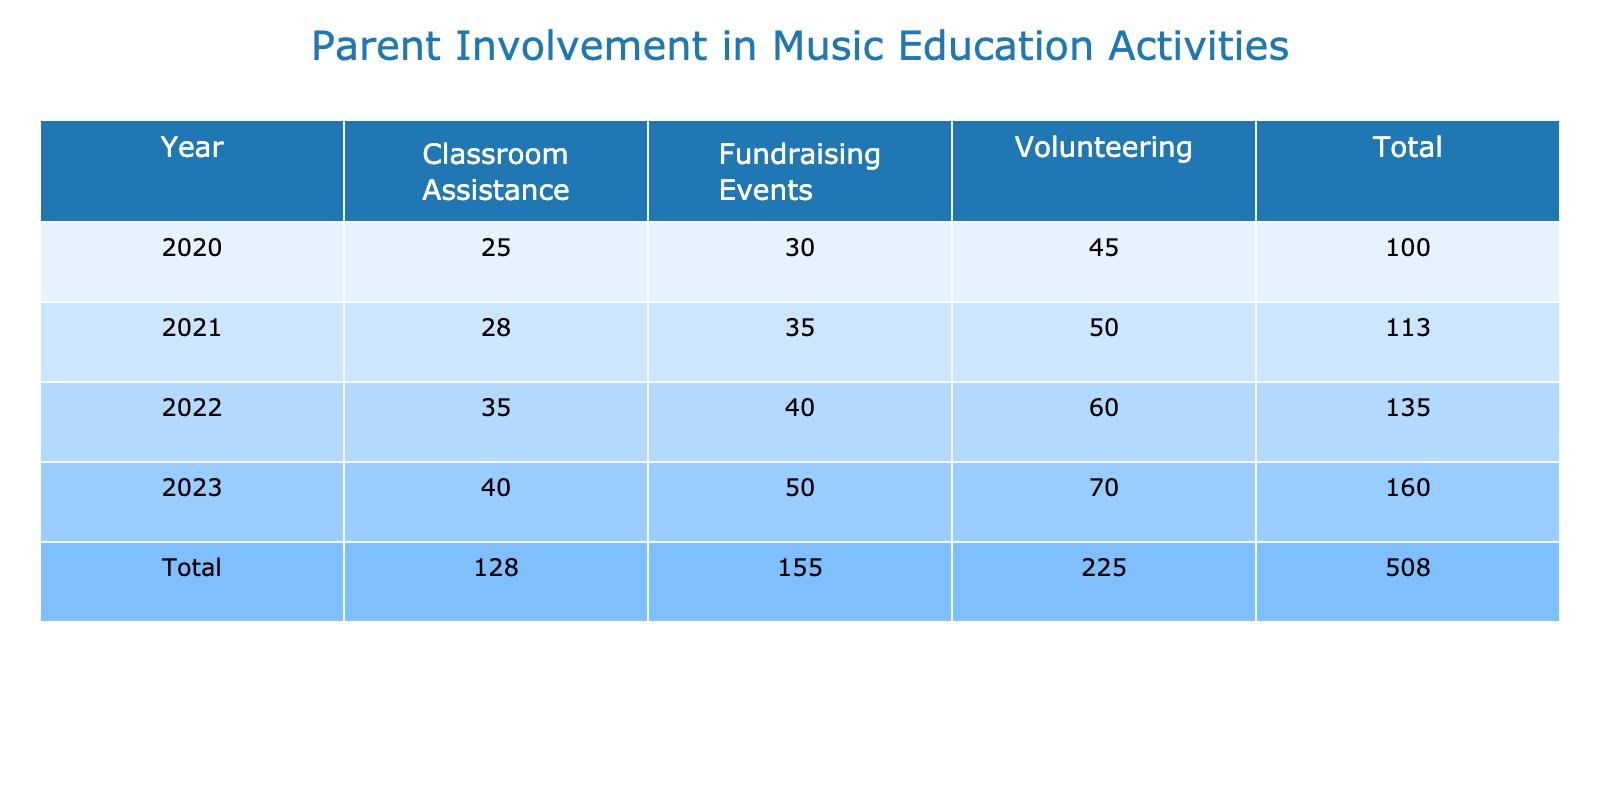What was the total number of parent involvements in 2020? To find the total for 2020, I add the number of involvements for each type of contribution in that year: 45 (Volunteering) + 30 (Fundraising Events) + 25 (Classroom Assistance) = 100.
Answer: 100 Which year had the highest number of parent involvements in Fundraising Events? Looking at the Fundraising Events row in the table, I see that 2023 had the highest involvement with 50 parents.
Answer: 2023 Was the number of parent involvements in Classroom Assistance higher in 2022 or 2021? In 2022, the number was 35, and in 2021 it was 28. Since 35 is greater than 28, Classroom Assistance had a higher involvement in 2022.
Answer: Yes What is the average number of parent involvements across all years for Volunteering? First, I gather the values for Volunteering: 45, 50, 60, 70. Then I sum these values: 45 + 50 + 60 + 70 = 225. The average is then 225 divided by 4, which equals 56.25.
Answer: 56.25 Did the total number of parent involvements increase every year from 2020 to 2023? I need to compare the total parent involvements year by year: 2020 had 100, 2021 had 113, 2022 had 135, and 2023 had 160. Since each year shows an increase from the previous one, the answer is yes.
Answer: Yes What was the difference in the number of parent involvements in Fundraising Events between 2021 and 2023? The number for 2021 is 35 and for 2023 it is 50. The difference is 50 - 35 = 15.
Answer: 15 Which contribution type had the lowest parent involvement in 2021? Looking at the numbers for 2021, the contributions are 50 (Volunteering), 35 (Fundraising Events), and 28 (Classroom Assistance). The lowest number is 28 from Classroom Assistance.
Answer: Classroom Assistance What was the total number of parent involvements for all years combined? I add together all the totals from each year: 100 (2020) + 113 (2021) + 135 (2022) + 160 (2023) = 508.
Answer: 508 How much did the number of parent involvements in Volunteering increase from 2020 to 2023? The Volunteering numbers are 45 in 2020 and 70 in 2023. The increase is 70 - 45 = 25.
Answer: 25 